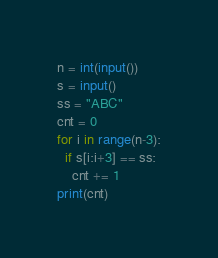<code> <loc_0><loc_0><loc_500><loc_500><_Python_>n = int(input())
s = input()
ss = "ABC"
cnt = 0
for i in range(n-3):
  if s[i:i+3] == ss:
    cnt += 1
print(cnt)</code> 